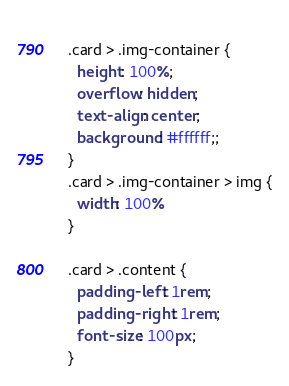<code> <loc_0><loc_0><loc_500><loc_500><_CSS_>  
  .card > .img-container {
    height: 100%;
    overflow: hidden;
    text-align: center;
    background: #ffffff;;
  }
  .card > .img-container > img {
    width: 100%
  }
  
  .card > .content {
    padding-left: 1rem;
    padding-right: 1rem;
    font-size: 100px;
  }</code> 